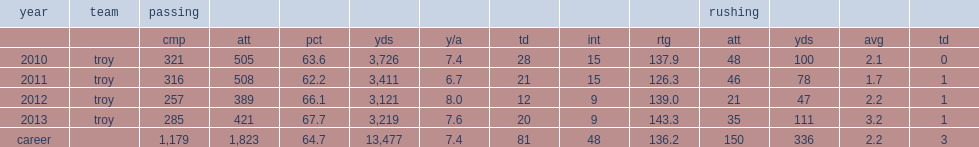How many passing yards did corey robinson get in 2010? 3726.0. 